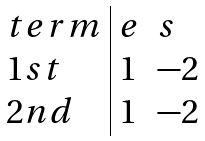<formula> <loc_0><loc_0><loc_500><loc_500>\begin{array} { l | l l } t e r m & e & s \\ 1 s t & 1 & - 2 \\ 2 n d & 1 & - 2 \\ \end{array}</formula> 